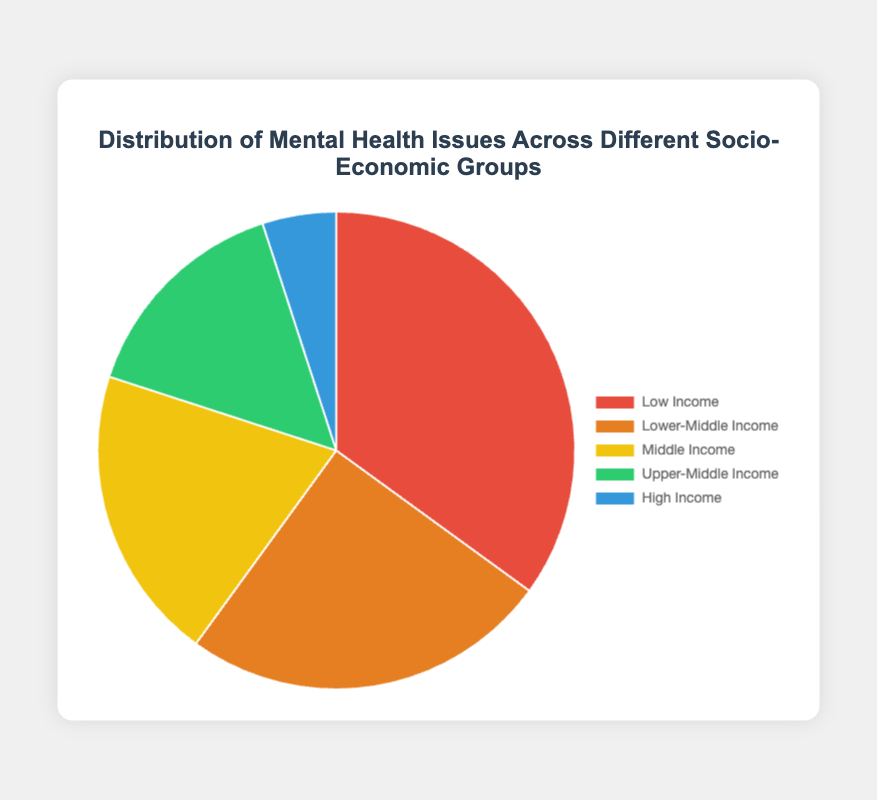What proportion of mental health issues are observed in the Low Income and Lower-Middle Income groups combined? Add the percentages for Low Income and Lower-Middle Income groups: 35% (Low Income) + 25% (Lower-Middle Income) = 60%
Answer: 60% Which socio-economic group has the least proportion of mental health issues? Look at the chart and find the group with the smallest value; it is 5% for the High Income group
Answer: High Income Is the proportion of mental health issues in Middle Income group more than that in the Upper-Middle Income group? Compare the percentages for Middle Income (20%) and Upper-Middle Income (15%); 20% is greater than 15%
Answer: Yes What is the difference in the proportion of mental health issues between the Low Income and High Income groups? Subtract the percentage of High Income from Low Income; 35% (Low Income) - 5% (High Income) = 30%
Answer: 30% What percentage of mental health issues are seen across Middle Income and Upper-Middle Income groups combined, compared to just the Low Income group? Add Middle Income and Upper-Middle Income: 20% + 15% = 35%. The Low Income group also has 35%. Therefore, the percentages are equal
Answer: Equal Calculate the average proportion of mental health issues across all socio-economic groups. Add all percentages: 35% + 25% + 20% + 15% + 5% = 100%. Divide by the number of groups: 100% / 5 = 20%
Answer: 20% Which group has a higher proportion of mental health issues: Lower-Middle Income or Upper-Middle Income? Compare the percentages for Lower-Middle Income (25%) and Upper-Middle Income (15%). 25% is greater than 15%
Answer: Lower-Middle Income Based on the colors, which group corresponds to the red section of the pie chart and what is their percentage? The red section corresponds to Low Income, which has a percentage of 35%
Answer: Low Income, 35% 